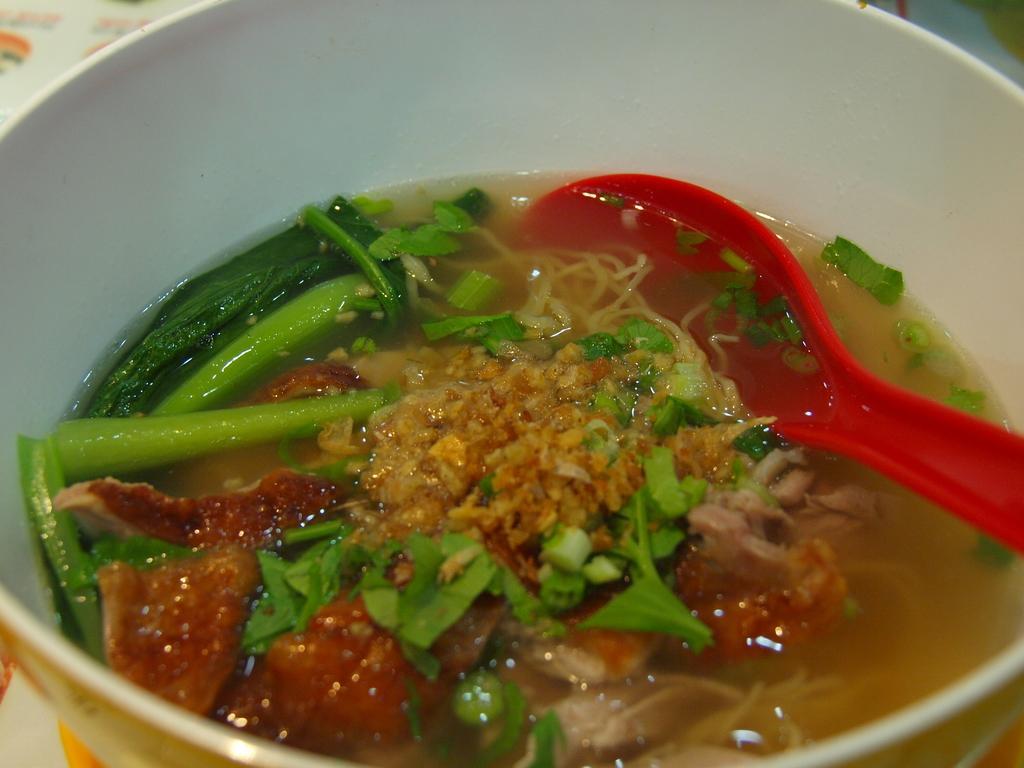Could you give a brief overview of what you see in this image? In this picture, we can see a table, on that table there is a bowl, in the bowl, we can see red color spoon with some food item with some liquid in it. 